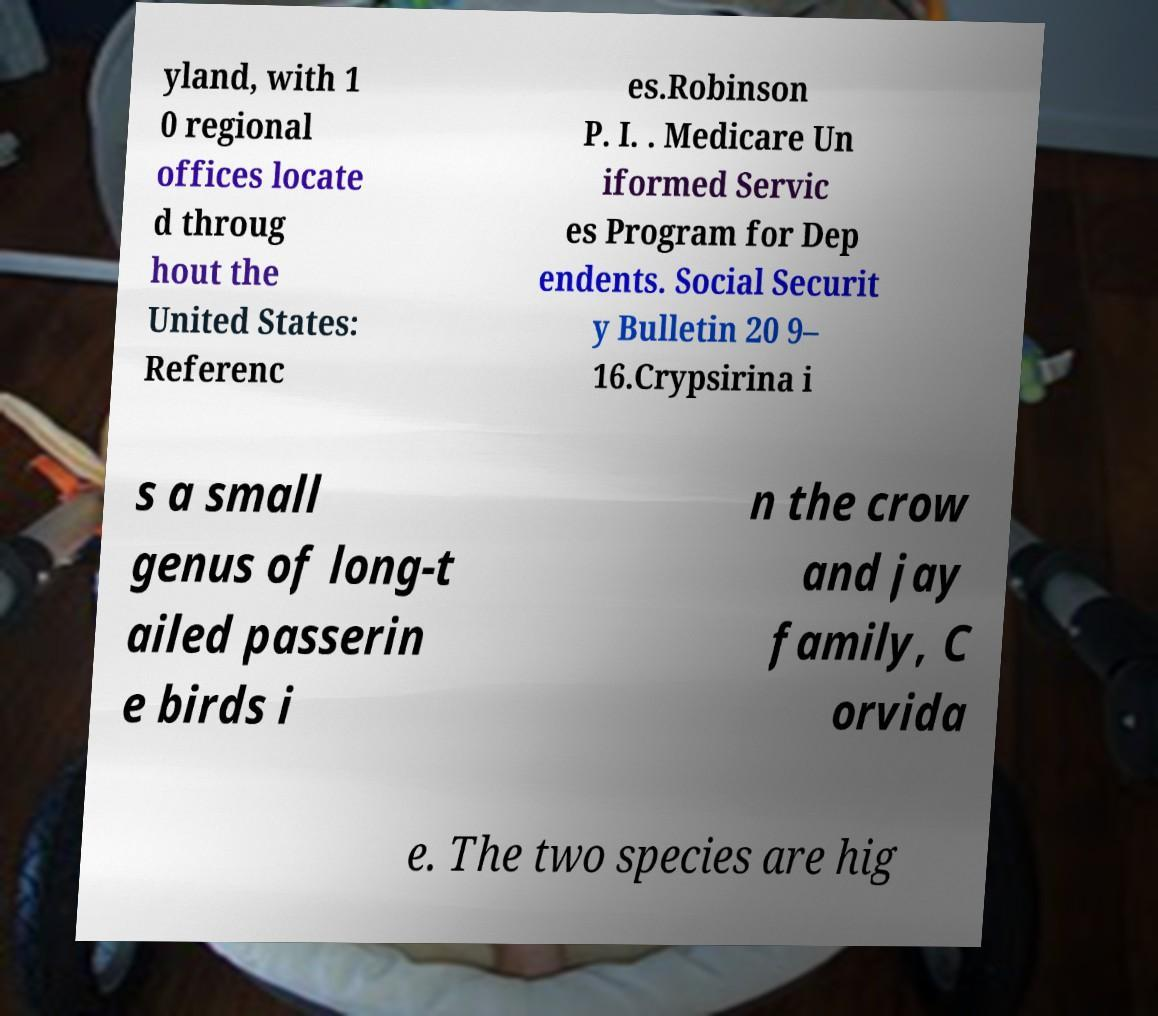Could you assist in decoding the text presented in this image and type it out clearly? yland, with 1 0 regional offices locate d throug hout the United States: Referenc es.Robinson P. I. . Medicare Un iformed Servic es Program for Dep endents. Social Securit y Bulletin 20 9– 16.Crypsirina i s a small genus of long-t ailed passerin e birds i n the crow and jay family, C orvida e. The two species are hig 